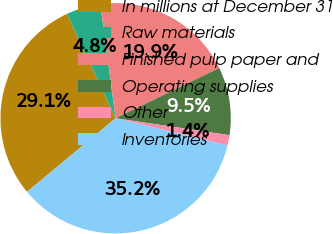Convert chart to OTSL. <chart><loc_0><loc_0><loc_500><loc_500><pie_chart><fcel>In millions at December 31<fcel>Raw materials<fcel>Finished pulp paper and<fcel>Operating supplies<fcel>Other<fcel>Inventories<nl><fcel>29.09%<fcel>4.82%<fcel>19.93%<fcel>9.54%<fcel>1.44%<fcel>35.18%<nl></chart> 